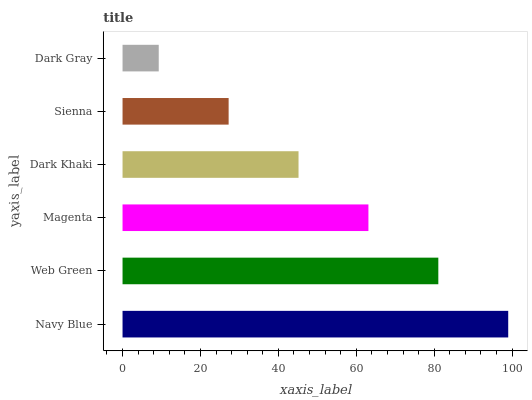Is Dark Gray the minimum?
Answer yes or no. Yes. Is Navy Blue the maximum?
Answer yes or no. Yes. Is Web Green the minimum?
Answer yes or no. No. Is Web Green the maximum?
Answer yes or no. No. Is Navy Blue greater than Web Green?
Answer yes or no. Yes. Is Web Green less than Navy Blue?
Answer yes or no. Yes. Is Web Green greater than Navy Blue?
Answer yes or no. No. Is Navy Blue less than Web Green?
Answer yes or no. No. Is Magenta the high median?
Answer yes or no. Yes. Is Dark Khaki the low median?
Answer yes or no. Yes. Is Dark Khaki the high median?
Answer yes or no. No. Is Dark Gray the low median?
Answer yes or no. No. 